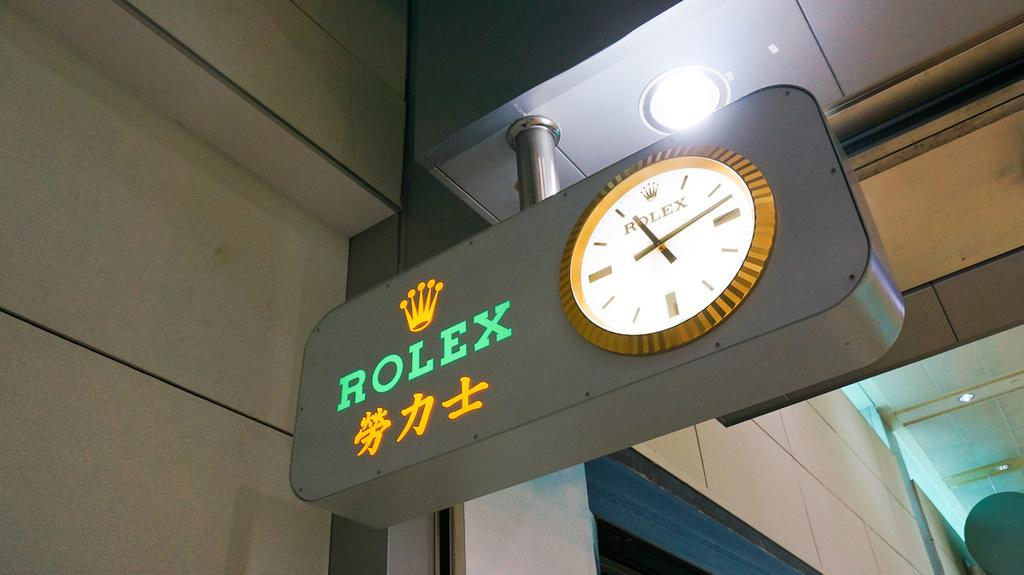<image>
Provide a brief description of the given image. A sign, hanging from a ceiling, says "Rolex" and has a clock on it that says "Rolex". 